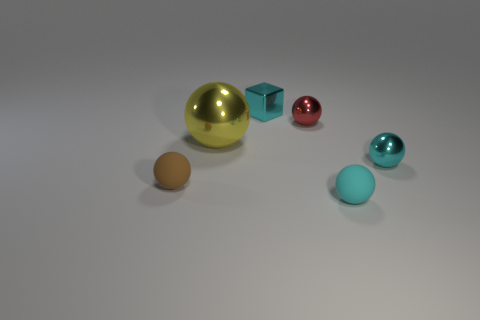Subtract 1 balls. How many balls are left? 4 Subtract all yellow balls. How many balls are left? 4 Subtract all red spheres. How many spheres are left? 4 Subtract all purple balls. Subtract all purple cubes. How many balls are left? 5 Add 3 tiny green metallic balls. How many objects exist? 9 Subtract all blocks. How many objects are left? 5 Add 6 cyan things. How many cyan things are left? 9 Add 2 tiny cyan balls. How many tiny cyan balls exist? 4 Subtract 0 purple spheres. How many objects are left? 6 Subtract all big green metal cylinders. Subtract all tiny matte things. How many objects are left? 4 